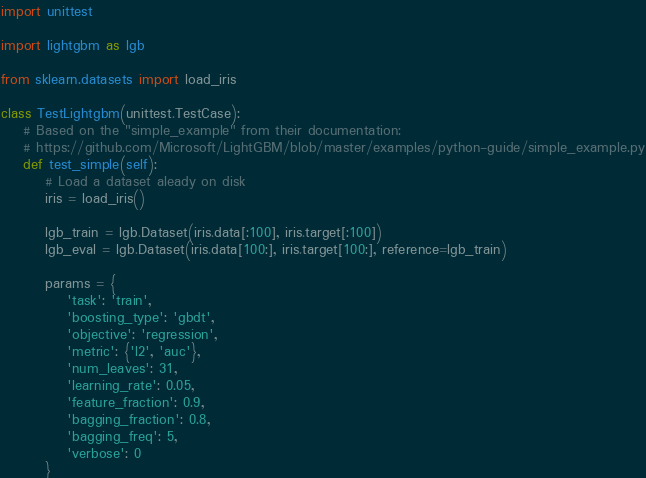<code> <loc_0><loc_0><loc_500><loc_500><_Python_>import unittest

import lightgbm as lgb

from sklearn.datasets import load_iris

class TestLightgbm(unittest.TestCase):
    # Based on the "simple_example" from their documentation:
    # https://github.com/Microsoft/LightGBM/blob/master/examples/python-guide/simple_example.py
    def test_simple(self):
        # Load a dataset aleady on disk
        iris = load_iris()

        lgb_train = lgb.Dataset(iris.data[:100], iris.target[:100])
        lgb_eval = lgb.Dataset(iris.data[100:], iris.target[100:], reference=lgb_train)

        params = {
            'task': 'train',
            'boosting_type': 'gbdt',
            'objective': 'regression',
            'metric': {'l2', 'auc'},
            'num_leaves': 31,
            'learning_rate': 0.05,
            'feature_fraction': 0.9,
            'bagging_fraction': 0.8,
            'bagging_freq': 5,
            'verbose': 0
        }
</code> 